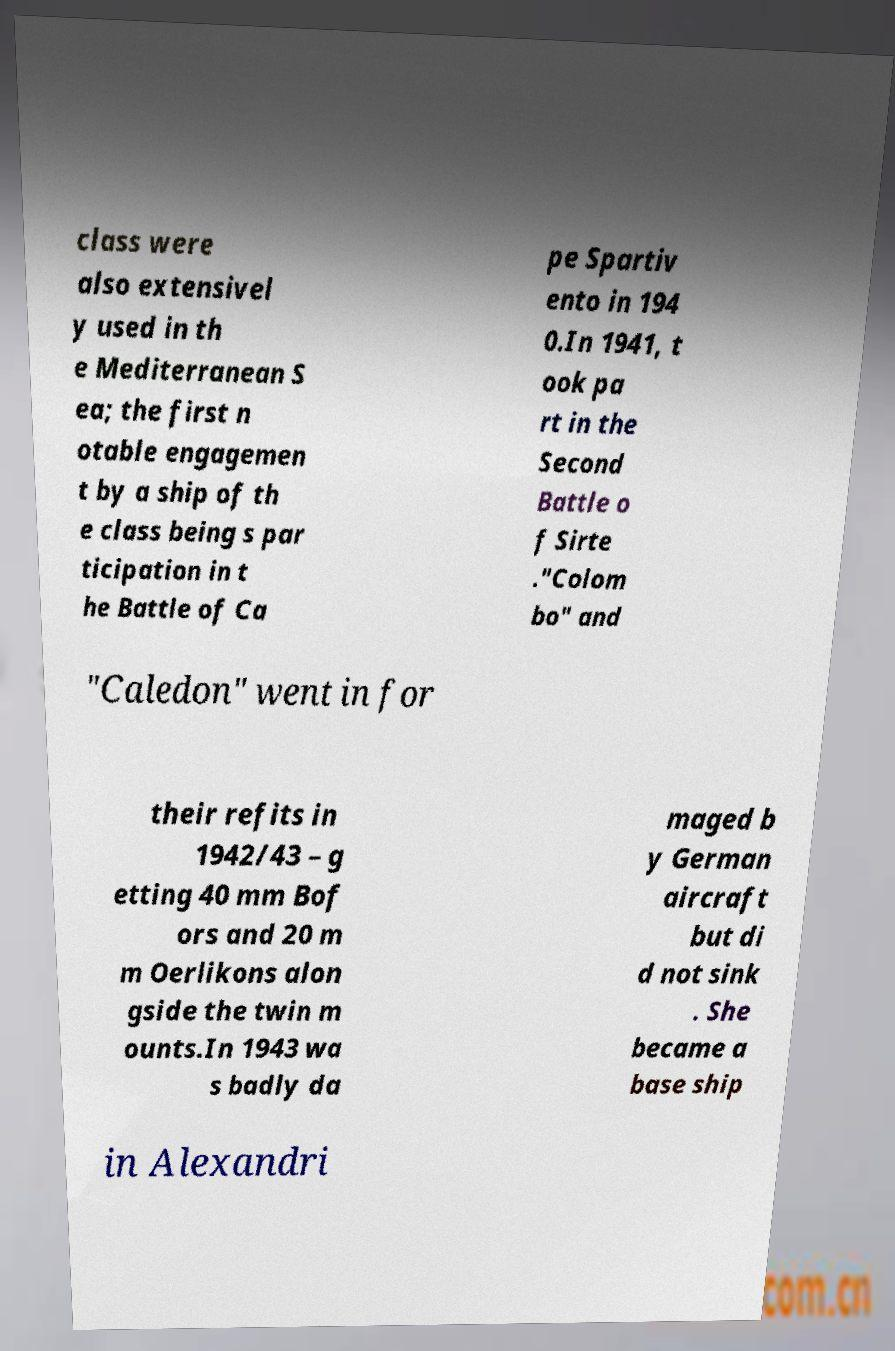For documentation purposes, I need the text within this image transcribed. Could you provide that? class were also extensivel y used in th e Mediterranean S ea; the first n otable engagemen t by a ship of th e class being s par ticipation in t he Battle of Ca pe Spartiv ento in 194 0.In 1941, t ook pa rt in the Second Battle o f Sirte ."Colom bo" and "Caledon" went in for their refits in 1942/43 – g etting 40 mm Bof ors and 20 m m Oerlikons alon gside the twin m ounts.In 1943 wa s badly da maged b y German aircraft but di d not sink . She became a base ship in Alexandri 